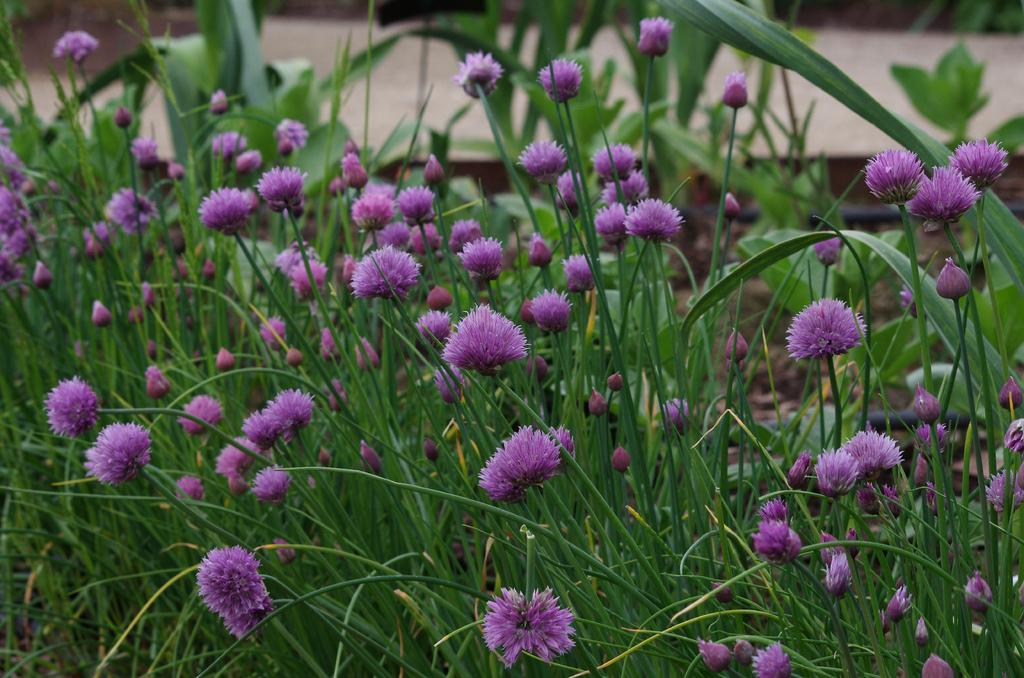What is present in the image? There is a plant in the image. What can be observed about the plant's flowers? The plant has purple flowers. What type of wrench is being used to adjust the channel in the image? There is no wrench or channel present in the image; it only features a plant with purple flowers. 